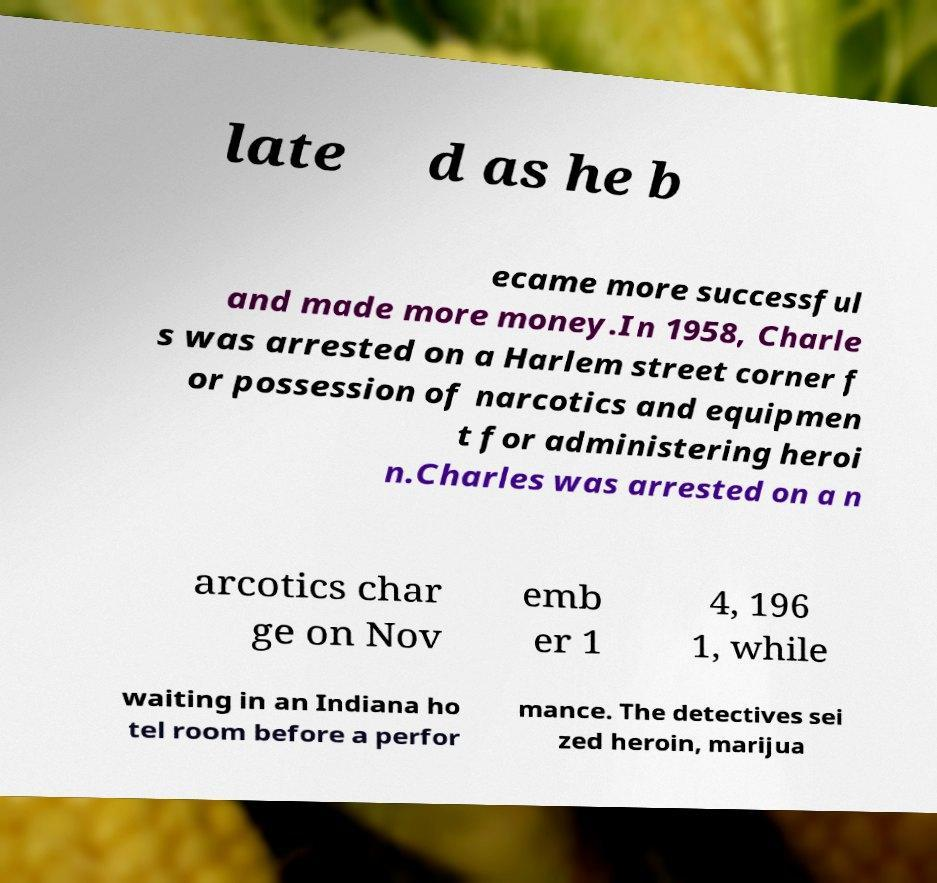For documentation purposes, I need the text within this image transcribed. Could you provide that? late d as he b ecame more successful and made more money.In 1958, Charle s was arrested on a Harlem street corner f or possession of narcotics and equipmen t for administering heroi n.Charles was arrested on a n arcotics char ge on Nov emb er 1 4, 196 1, while waiting in an Indiana ho tel room before a perfor mance. The detectives sei zed heroin, marijua 